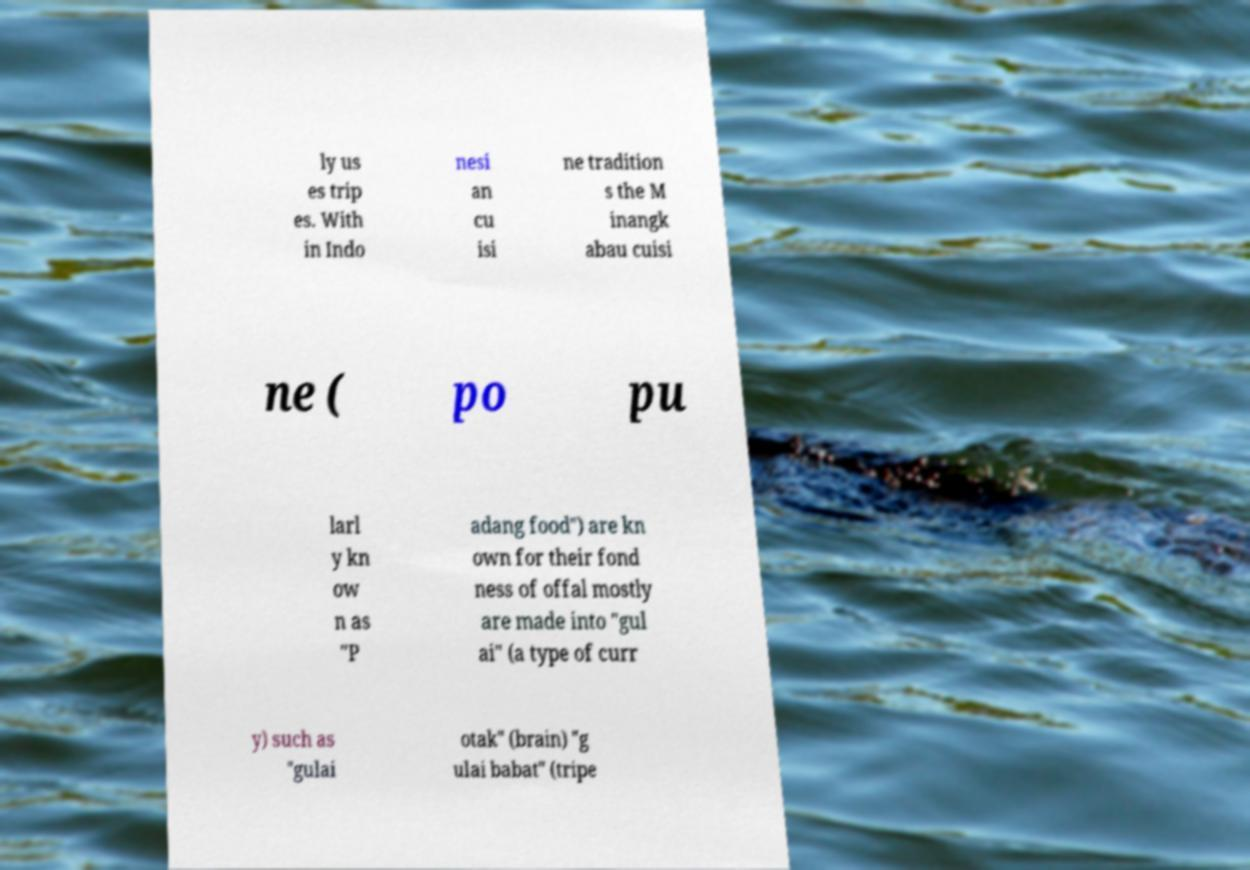Can you accurately transcribe the text from the provided image for me? ly us es trip es. With in Indo nesi an cu isi ne tradition s the M inangk abau cuisi ne ( po pu larl y kn ow n as "P adang food") are kn own for their fond ness of offal mostly are made into "gul ai" (a type of curr y) such as "gulai otak" (brain) "g ulai babat" (tripe 